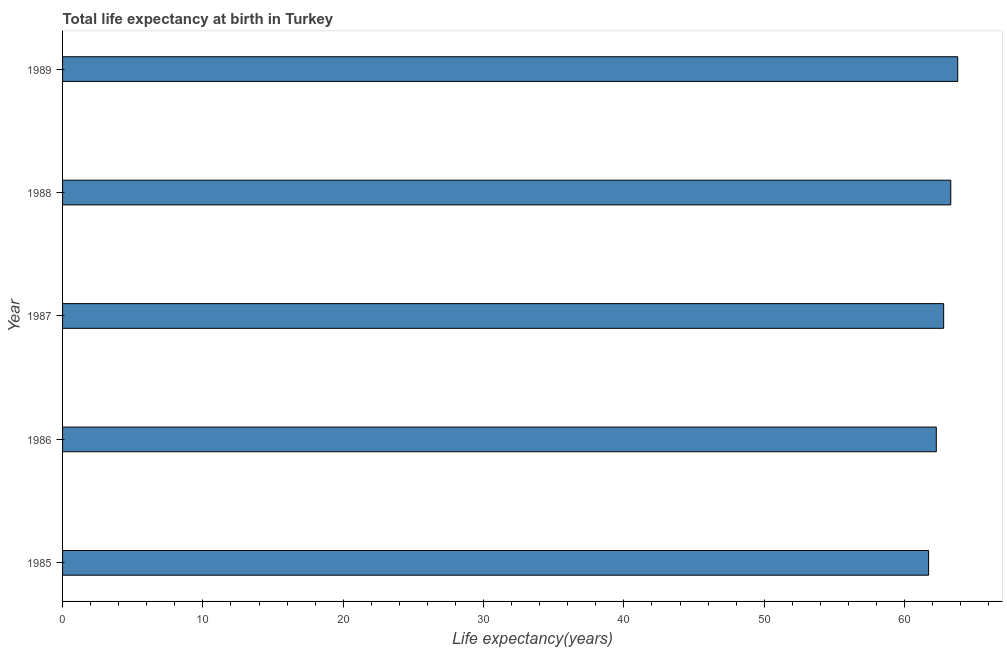Does the graph contain any zero values?
Give a very brief answer. No. Does the graph contain grids?
Your response must be concise. No. What is the title of the graph?
Make the answer very short. Total life expectancy at birth in Turkey. What is the label or title of the X-axis?
Keep it short and to the point. Life expectancy(years). What is the label or title of the Y-axis?
Keep it short and to the point. Year. What is the life expectancy at birth in 1985?
Ensure brevity in your answer.  61.71. Across all years, what is the maximum life expectancy at birth?
Your answer should be compact. 63.79. Across all years, what is the minimum life expectancy at birth?
Give a very brief answer. 61.71. In which year was the life expectancy at birth minimum?
Make the answer very short. 1985. What is the sum of the life expectancy at birth?
Your response must be concise. 313.85. What is the difference between the life expectancy at birth in 1986 and 1989?
Your response must be concise. -1.53. What is the average life expectancy at birth per year?
Your response must be concise. 62.77. What is the median life expectancy at birth?
Ensure brevity in your answer.  62.79. Do a majority of the years between 1985 and 1988 (inclusive) have life expectancy at birth greater than 32 years?
Your response must be concise. Yes. What is the ratio of the life expectancy at birth in 1987 to that in 1988?
Make the answer very short. 0.99. Is the life expectancy at birth in 1987 less than that in 1988?
Ensure brevity in your answer.  Yes. What is the difference between the highest and the second highest life expectancy at birth?
Give a very brief answer. 0.5. What is the difference between the highest and the lowest life expectancy at birth?
Make the answer very short. 2.08. In how many years, is the life expectancy at birth greater than the average life expectancy at birth taken over all years?
Your answer should be compact. 3. How many bars are there?
Provide a succinct answer. 5. Are all the bars in the graph horizontal?
Your response must be concise. Yes. How many years are there in the graph?
Offer a terse response. 5. What is the difference between two consecutive major ticks on the X-axis?
Your answer should be compact. 10. Are the values on the major ticks of X-axis written in scientific E-notation?
Your answer should be compact. No. What is the Life expectancy(years) in 1985?
Your answer should be compact. 61.71. What is the Life expectancy(years) in 1986?
Provide a short and direct response. 62.26. What is the Life expectancy(years) in 1987?
Provide a short and direct response. 62.79. What is the Life expectancy(years) in 1988?
Offer a very short reply. 63.29. What is the Life expectancy(years) in 1989?
Ensure brevity in your answer.  63.79. What is the difference between the Life expectancy(years) in 1985 and 1986?
Keep it short and to the point. -0.55. What is the difference between the Life expectancy(years) in 1985 and 1987?
Ensure brevity in your answer.  -1.07. What is the difference between the Life expectancy(years) in 1985 and 1988?
Offer a very short reply. -1.58. What is the difference between the Life expectancy(years) in 1985 and 1989?
Your answer should be very brief. -2.08. What is the difference between the Life expectancy(years) in 1986 and 1987?
Provide a short and direct response. -0.53. What is the difference between the Life expectancy(years) in 1986 and 1988?
Provide a succinct answer. -1.03. What is the difference between the Life expectancy(years) in 1986 and 1989?
Ensure brevity in your answer.  -1.53. What is the difference between the Life expectancy(years) in 1987 and 1988?
Offer a very short reply. -0.51. What is the difference between the Life expectancy(years) in 1987 and 1989?
Make the answer very short. -1. What is the difference between the Life expectancy(years) in 1988 and 1989?
Keep it short and to the point. -0.5. What is the ratio of the Life expectancy(years) in 1985 to that in 1988?
Give a very brief answer. 0.97. What is the ratio of the Life expectancy(years) in 1985 to that in 1989?
Keep it short and to the point. 0.97. What is the ratio of the Life expectancy(years) in 1986 to that in 1987?
Your response must be concise. 0.99. 